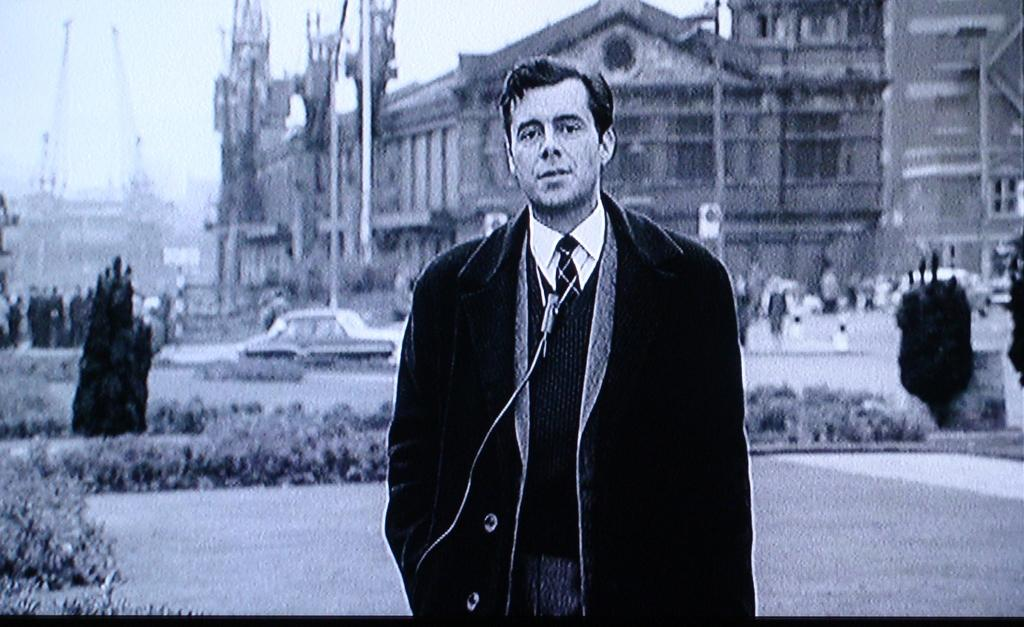What is the main subject of the image? There is a person standing in the image. What is the person wearing? The person is wearing a coat. What type of vegetation can be seen in the image? There are plants visible in the image. What type of man-made structure can be seen in the image? There is a car and buildings visible in the image. What is the income of the wren perched on the car in the image? There is no wren present in the image, and therefore no income can be attributed to it. 